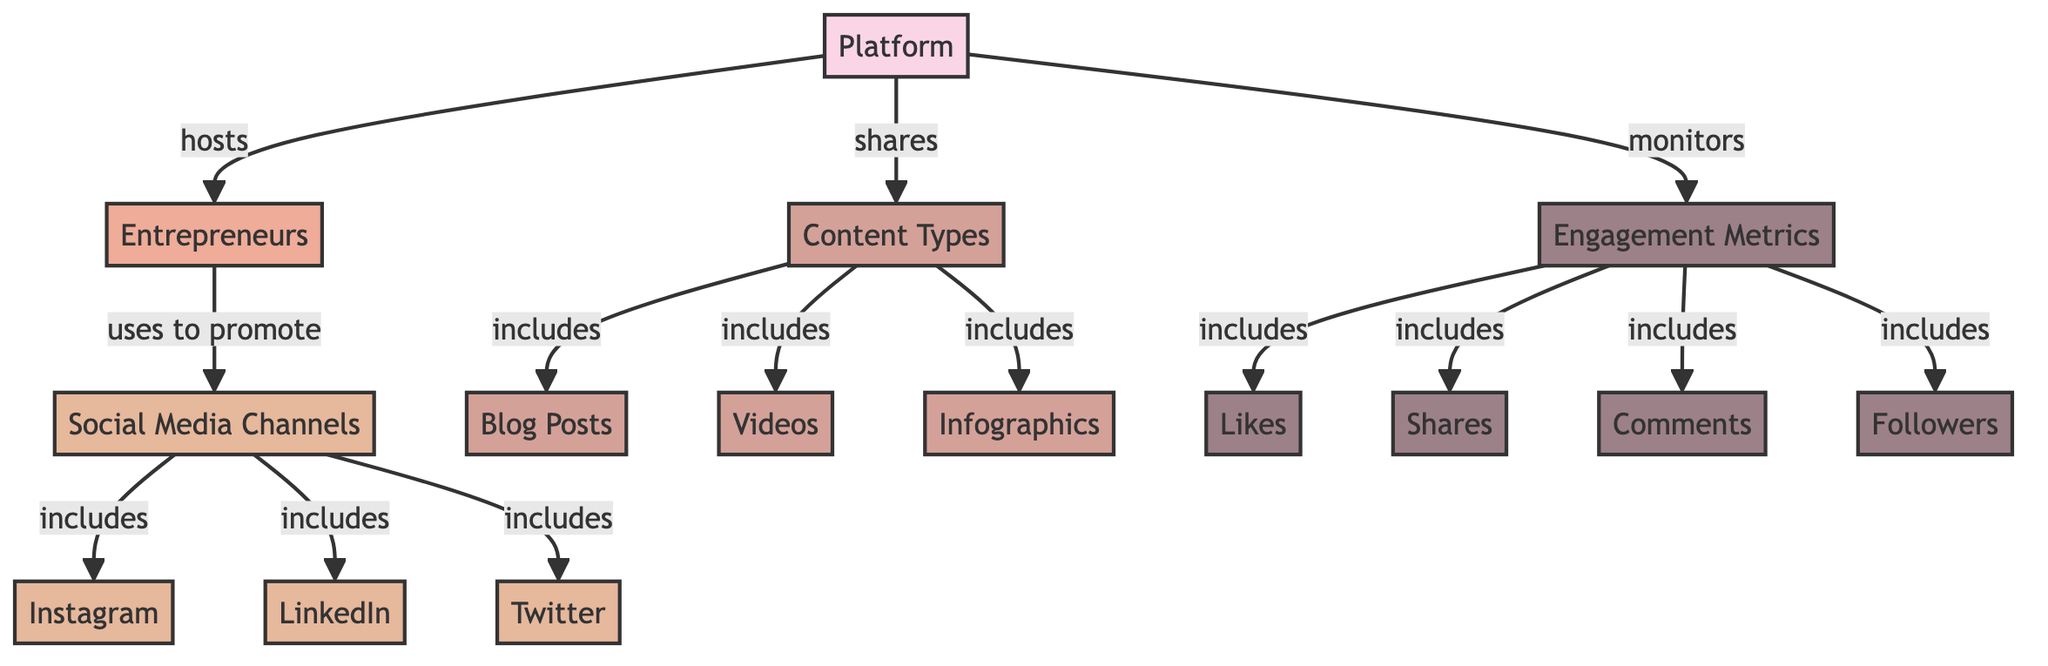What's the total number of nodes in the diagram? The diagram lists various distinct elements, which are classified as nodes. Counting them provides the total number of nodes, which is 15.
Answer: 15 What content type is included in the diagram? By examining the diagram, the specific content types listed include blog posts, videos, and infographics. Therefore, these three types fall under the content category.
Answer: Blog Posts, Videos, Infographics What social media channel has the label "includes" connected to it? The edges in the diagram indicate that social media channels include Instagram, LinkedIn, and Twitter. This means they share a connection through the label "includes."
Answer: Instagram, LinkedIn, Twitter How many engagement metrics are mentioned in the diagram? The diagram outlines engagement metrics, which include likes, shares, comments, and followers. By counting these distinct metrics, we find a total of four metrics.
Answer: 4 Which node monitors the engagement metrics? According to the diagram, the platform node is responsible for monitoring the engagement metrics. It connects directly to the engagement metrics node.
Answer: Platform What is the relationship between entrepreneurs and social media channels? Analyzing the connections from the diagram shows that entrepreneurs utilize social media channels to promote their businesses. This indicates a direct influence or dependence relation.
Answer: Uses to promote What are the types of content shared on social media? The diagram illustrates that the platform shares various types of content on social media, specifically including blog posts, videos, and infographics.
Answer: Blog Posts, Videos, Infographics In total, how many edges are there in the diagram? To find the total number of edges, we count the connections between the nodes in the diagram. Upon inspection, there are 13 edges.
Answer: 13 What is the direct engagement metric that shows a count of followers? From the engagement metrics in the diagram, the specific engagement metric linked to counting followers is explicitly named "Followers."
Answer: Followers How many social media channels are included? The social media channels listed in the diagram are Instagram, LinkedIn, and Twitter. Counting these gives a total of three distinct social media channels included.
Answer: 3 